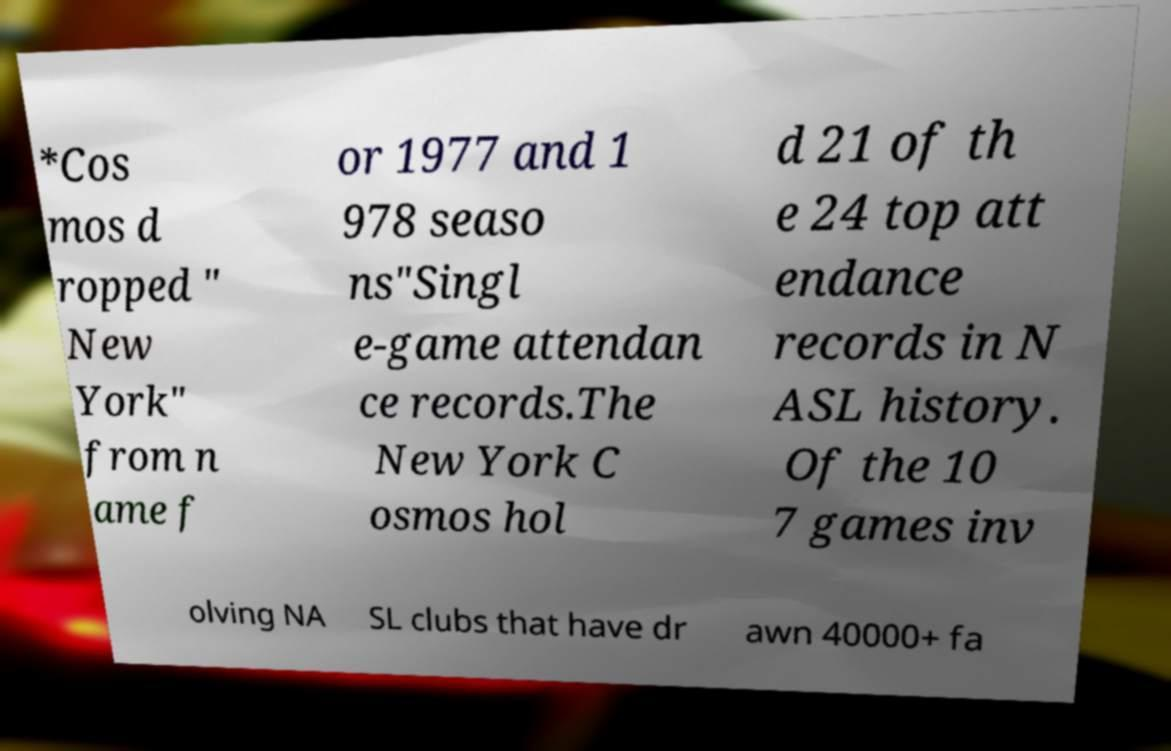Could you assist in decoding the text presented in this image and type it out clearly? *Cos mos d ropped " New York" from n ame f or 1977 and 1 978 seaso ns"Singl e-game attendan ce records.The New York C osmos hol d 21 of th e 24 top att endance records in N ASL history. Of the 10 7 games inv olving NA SL clubs that have dr awn 40000+ fa 